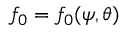Convert formula to latex. <formula><loc_0><loc_0><loc_500><loc_500>f _ { 0 } = f _ { 0 } ( \psi , \theta )</formula> 